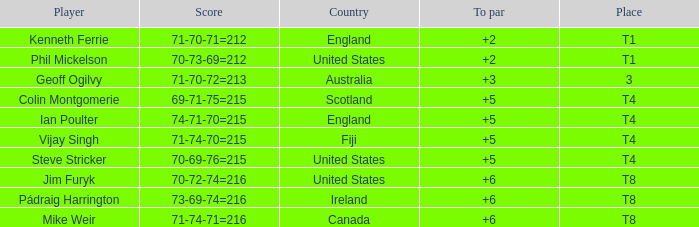What was mike weir's score in relation to par? 6.0. 